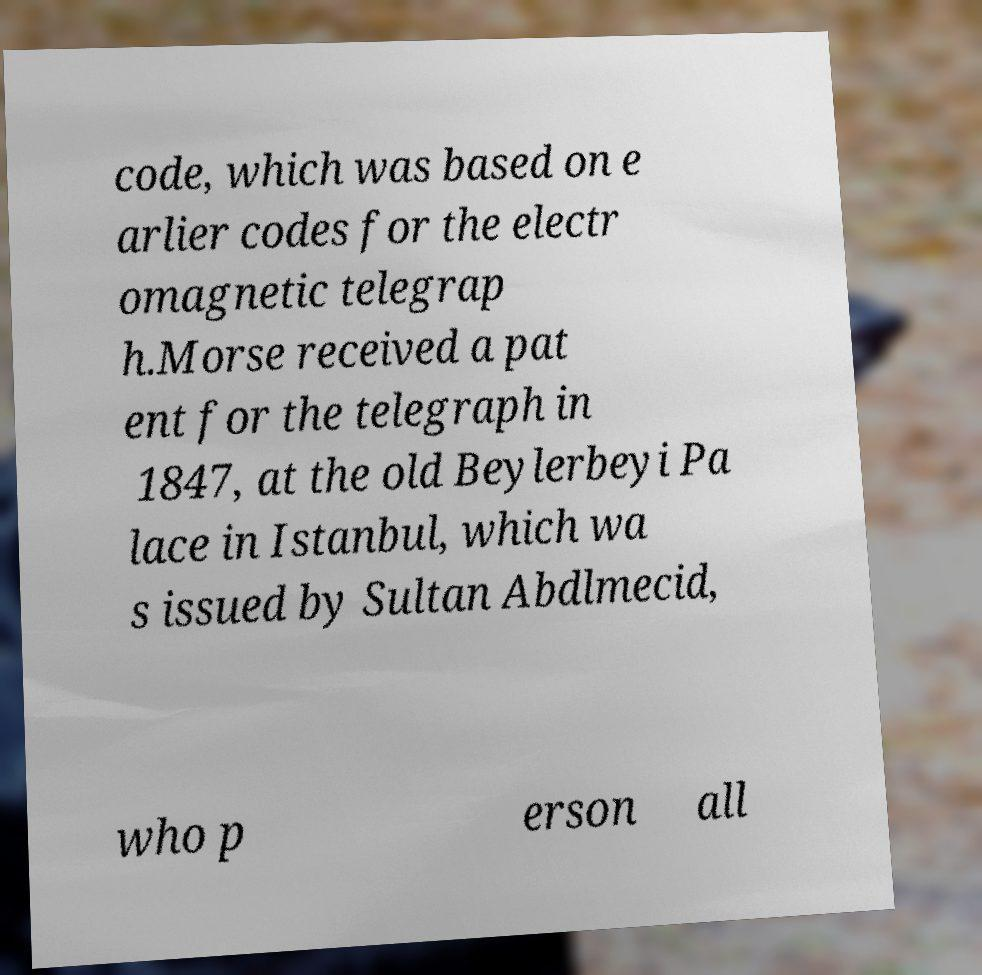For documentation purposes, I need the text within this image transcribed. Could you provide that? code, which was based on e arlier codes for the electr omagnetic telegrap h.Morse received a pat ent for the telegraph in 1847, at the old Beylerbeyi Pa lace in Istanbul, which wa s issued by Sultan Abdlmecid, who p erson all 